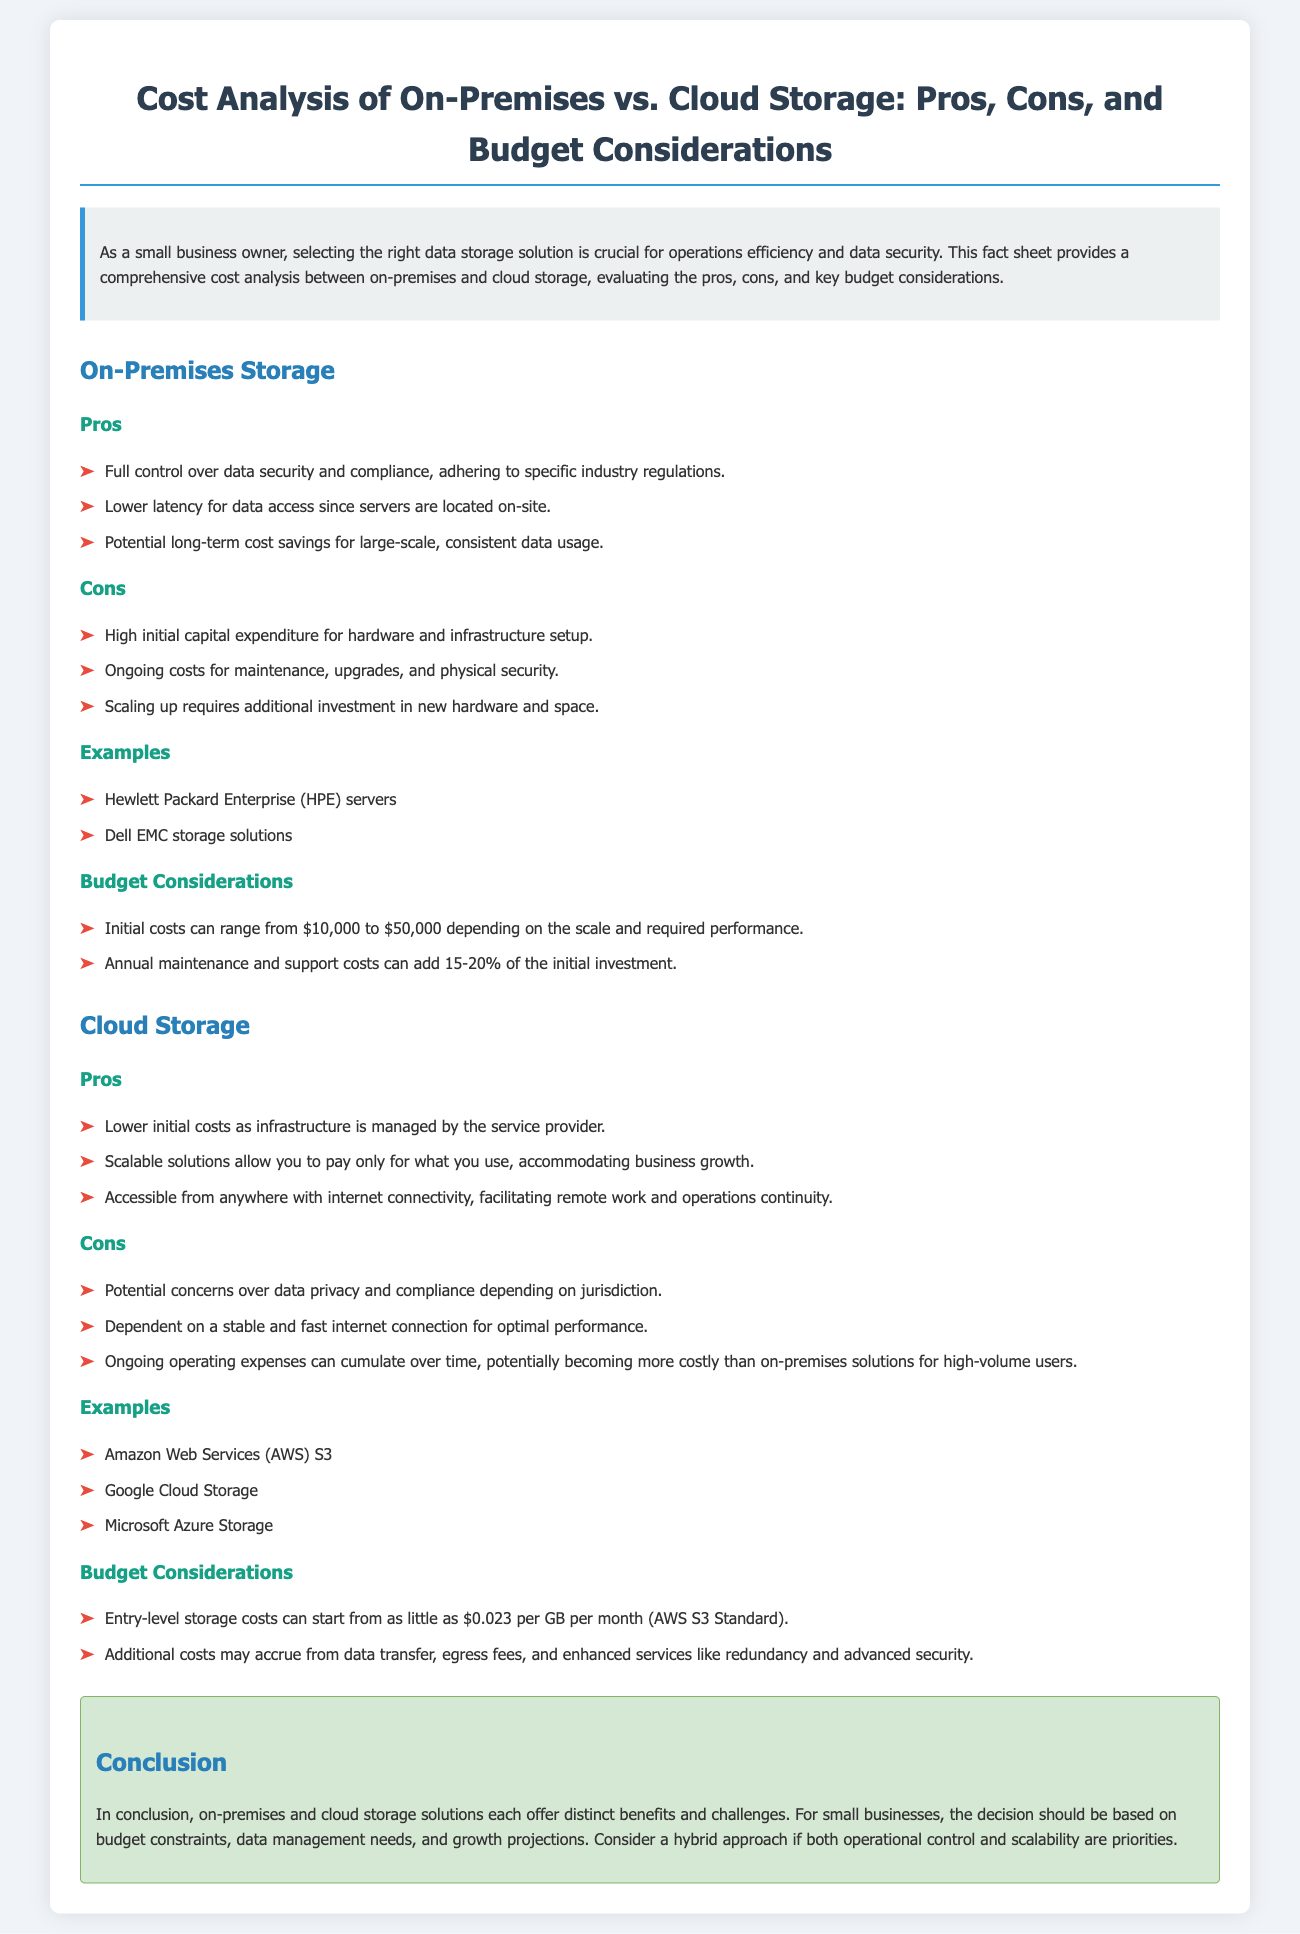what is the initial cost range for on-premises storage? The initial costs can range from $10,000 to $50,000 depending on the scale and required performance.
Answer: $10,000 to $50,000 what are the pros of cloud storage? The document lists benefits of cloud storage including lower initial costs, scalability, and accessibility.
Answer: Lower initial costs, scalable solutions, accessible from anywhere what is a potential con of on-premises storage? The document highlights high initial capital expenditure for hardware and infrastructure setup as a drawback.
Answer: High initial capital expenditure name two examples of cloud storage providers mentioned. The document provides examples like Amazon Web Services and Google Cloud Storage.
Answer: Amazon Web Services, Google Cloud Storage what percentage of the initial investment does annual maintenance and support add for on-premises solutions? The yearly costs for maintenance and support can add 15-20% of the initial investment.
Answer: 15-20% what is the starting cost for entry-level cloud storage per GB per month? The document states that entry-level storage costs can start from as little as $0.023 per GB per month.
Answer: $0.023 per GB per month what is the main consideration for deciding between on-premises and cloud storage? The decision should be based on budget constraints, data management needs, and growth projections.
Answer: Budget constraints, data management needs, growth projections how does on-premises storage impact data access latency? The document mentions that on-premises storage provides lower latency for data access.
Answer: Lower latency 